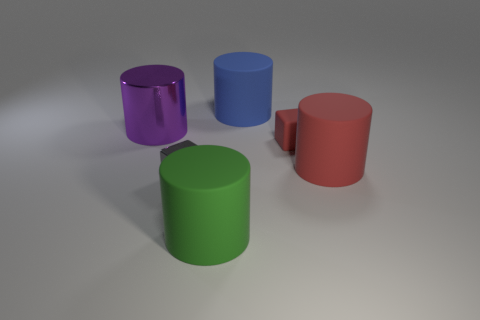There is a big cylinder to the right of the small block that is behind the red matte cylinder; what is its material?
Your response must be concise. Rubber. Is there a gray metal thing?
Your answer should be compact. Yes. There is a matte block behind the large matte object that is in front of the gray metal block; what size is it?
Keep it short and to the point. Small. Is the number of gray things that are in front of the tiny matte cube greater than the number of small red rubber things in front of the big red thing?
Provide a succinct answer. Yes. What number of blocks are large objects or big green objects?
Your response must be concise. 0. Does the large object on the left side of the tiny gray shiny object have the same shape as the green thing?
Offer a very short reply. Yes. The big metallic cylinder has what color?
Provide a short and direct response. Purple. What is the color of the other thing that is the same shape as the gray metal object?
Make the answer very short. Red. What number of large red matte objects have the same shape as the large purple shiny object?
Keep it short and to the point. 1. What number of objects are either big purple objects or large things that are in front of the large purple thing?
Keep it short and to the point. 3. 